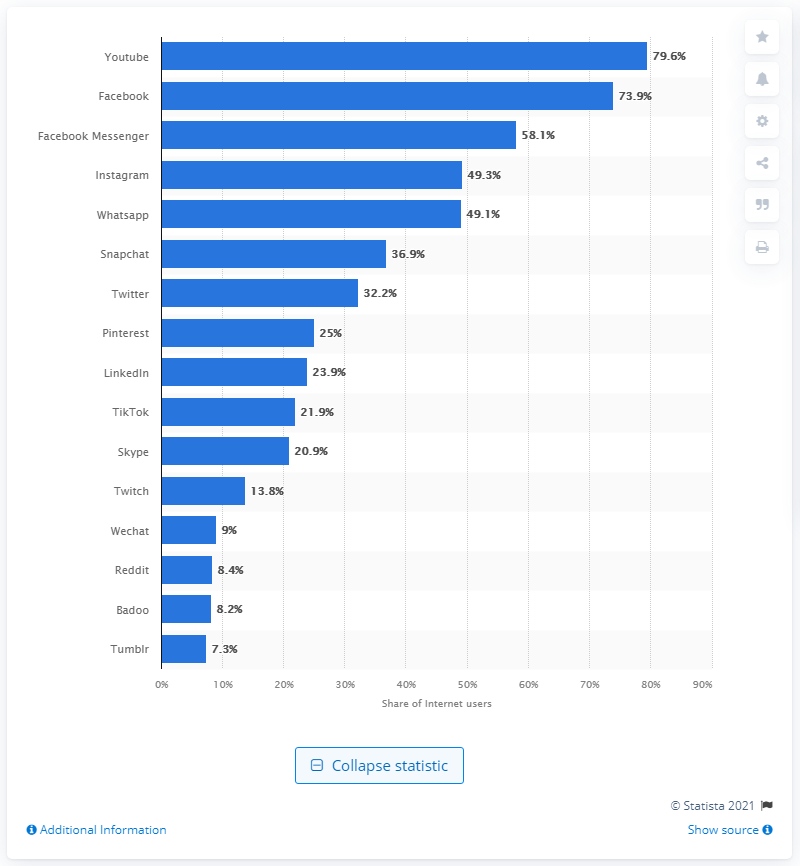Indicate a few pertinent items in this graphic. According to the third quarter of 2020, Whatsapp was the second most popular social network in France. 